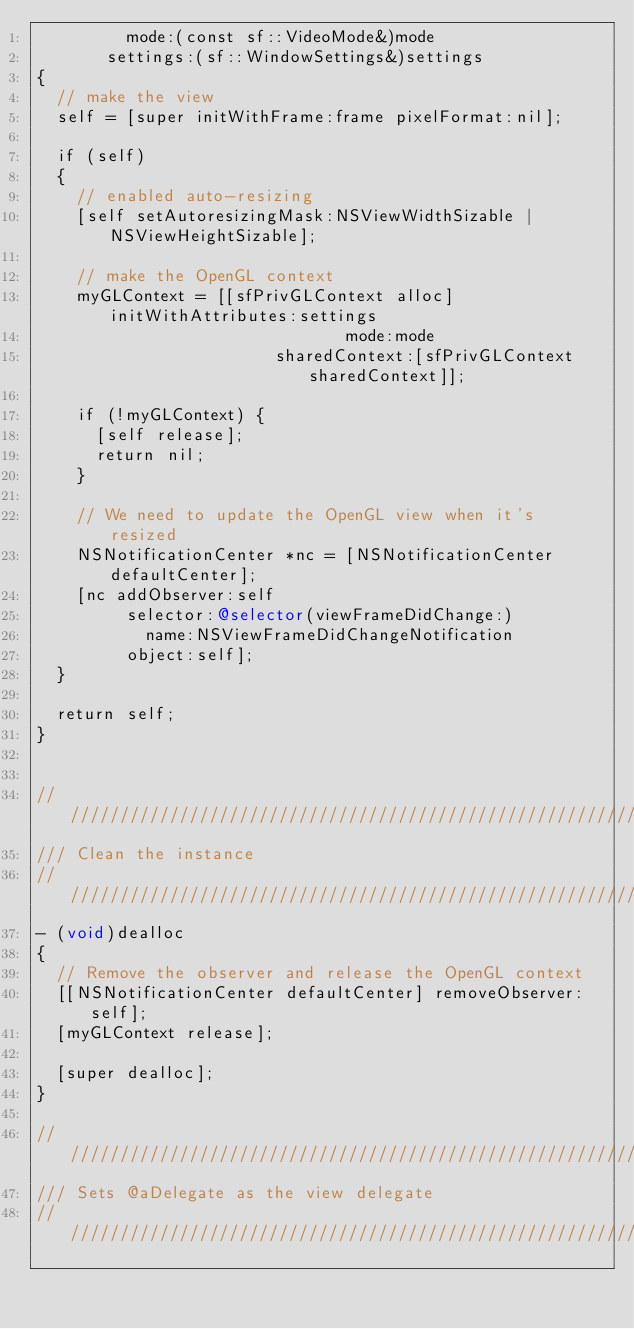Convert code to text. <code><loc_0><loc_0><loc_500><loc_500><_ObjectiveC_>			   mode:(const sf::VideoMode&)mode
		   settings:(sf::WindowSettings&)settings
{
	// make the view
	self = [super initWithFrame:frame pixelFormat:nil];
	
	if (self)
	{
		// enabled auto-resizing
		[self setAutoresizingMask:NSViewWidthSizable | NSViewHeightSizable];
		
		// make the OpenGL context
		myGLContext = [[sfPrivGLContext alloc] initWithAttributes:settings
															 mode:mode
											  sharedContext:[sfPrivGLContext sharedContext]];
		
		if (!myGLContext) {
			[self release];
			return nil;
		}
		
		// We need to update the OpenGL view when it's resized
		NSNotificationCenter *nc = [NSNotificationCenter defaultCenter];
		[nc addObserver:self
			   selector:@selector(viewFrameDidChange:)
				   name:NSViewFrameDidChangeNotification
				 object:self];
	}
	
	return self;
}


////////////////////////////////////////////////////////////
/// Clean the instance
////////////////////////////////////////////////////////////
- (void)dealloc
{
	// Remove the observer and release the OpenGL context
	[[NSNotificationCenter defaultCenter] removeObserver:self];
	[myGLContext release];
	
	[super dealloc];
}

////////////////////////////////////////////////////////////
/// Sets @aDelegate as the view delegate
////////////////////////////////////////////////////////////</code> 